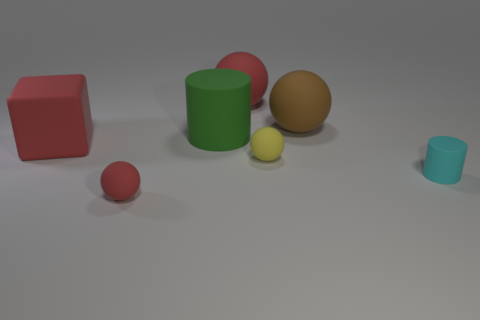Subtract all blue blocks. How many red balls are left? 2 Subtract all small red rubber balls. How many balls are left? 3 Subtract all brown balls. How many balls are left? 3 Add 3 yellow cylinders. How many objects exist? 10 Subtract all green balls. Subtract all gray cylinders. How many balls are left? 4 Subtract all cylinders. How many objects are left? 5 Add 4 big green objects. How many big green objects are left? 5 Add 7 red metal balls. How many red metal balls exist? 7 Subtract 0 gray blocks. How many objects are left? 7 Subtract all small cyan things. Subtract all large blue spheres. How many objects are left? 6 